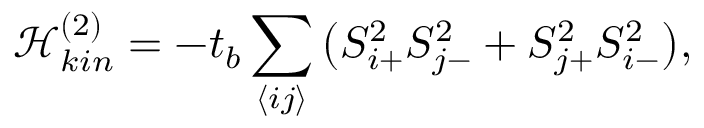Convert formula to latex. <formula><loc_0><loc_0><loc_500><loc_500>\mathcal { H } _ { k i n } ^ { ( 2 ) } = - t _ { b } \sum _ { \left \langle i j \right \rangle } \left ( S _ { i { + } } ^ { 2 } S _ { j { - } } ^ { 2 } + S _ { j { + } } ^ { 2 } S _ { i { - } } ^ { 2 } \right ) ,</formula> 